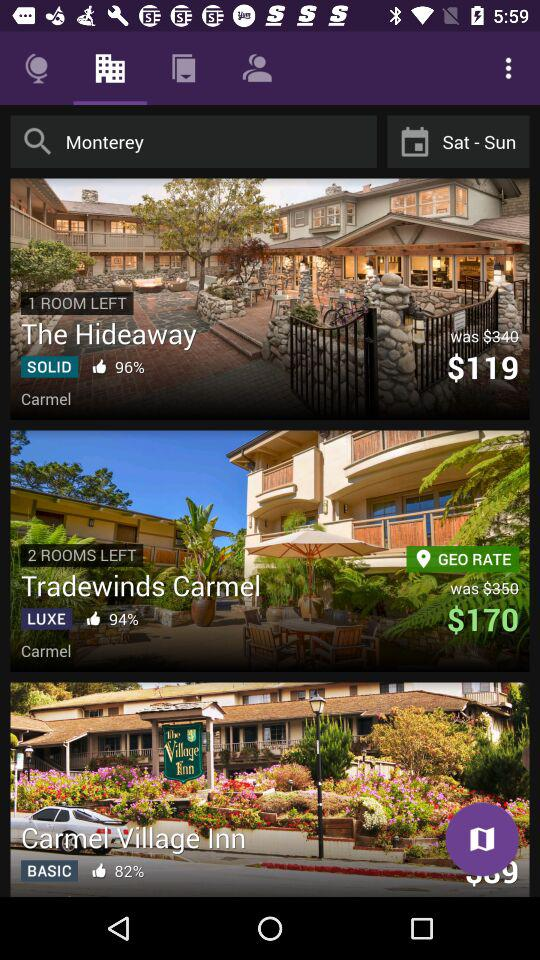What is the percentage of likes for "Tradewinds Carmel"? The percentage of likes is 94. 